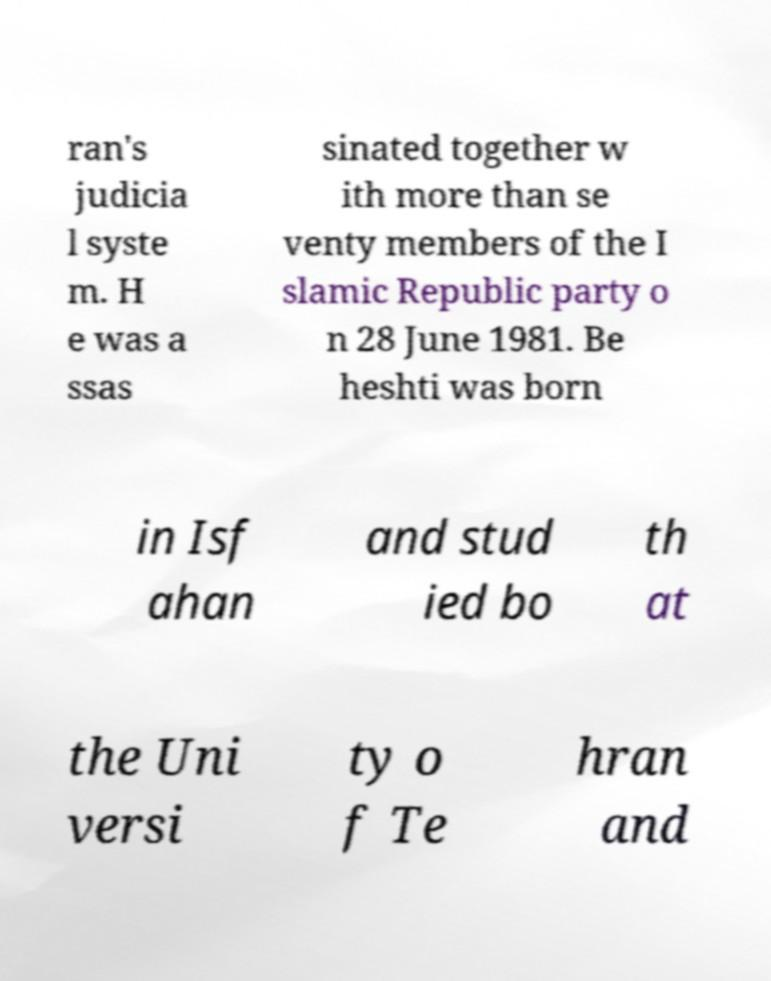I need the written content from this picture converted into text. Can you do that? ran's judicia l syste m. H e was a ssas sinated together w ith more than se venty members of the I slamic Republic party o n 28 June 1981. Be heshti was born in Isf ahan and stud ied bo th at the Uni versi ty o f Te hran and 